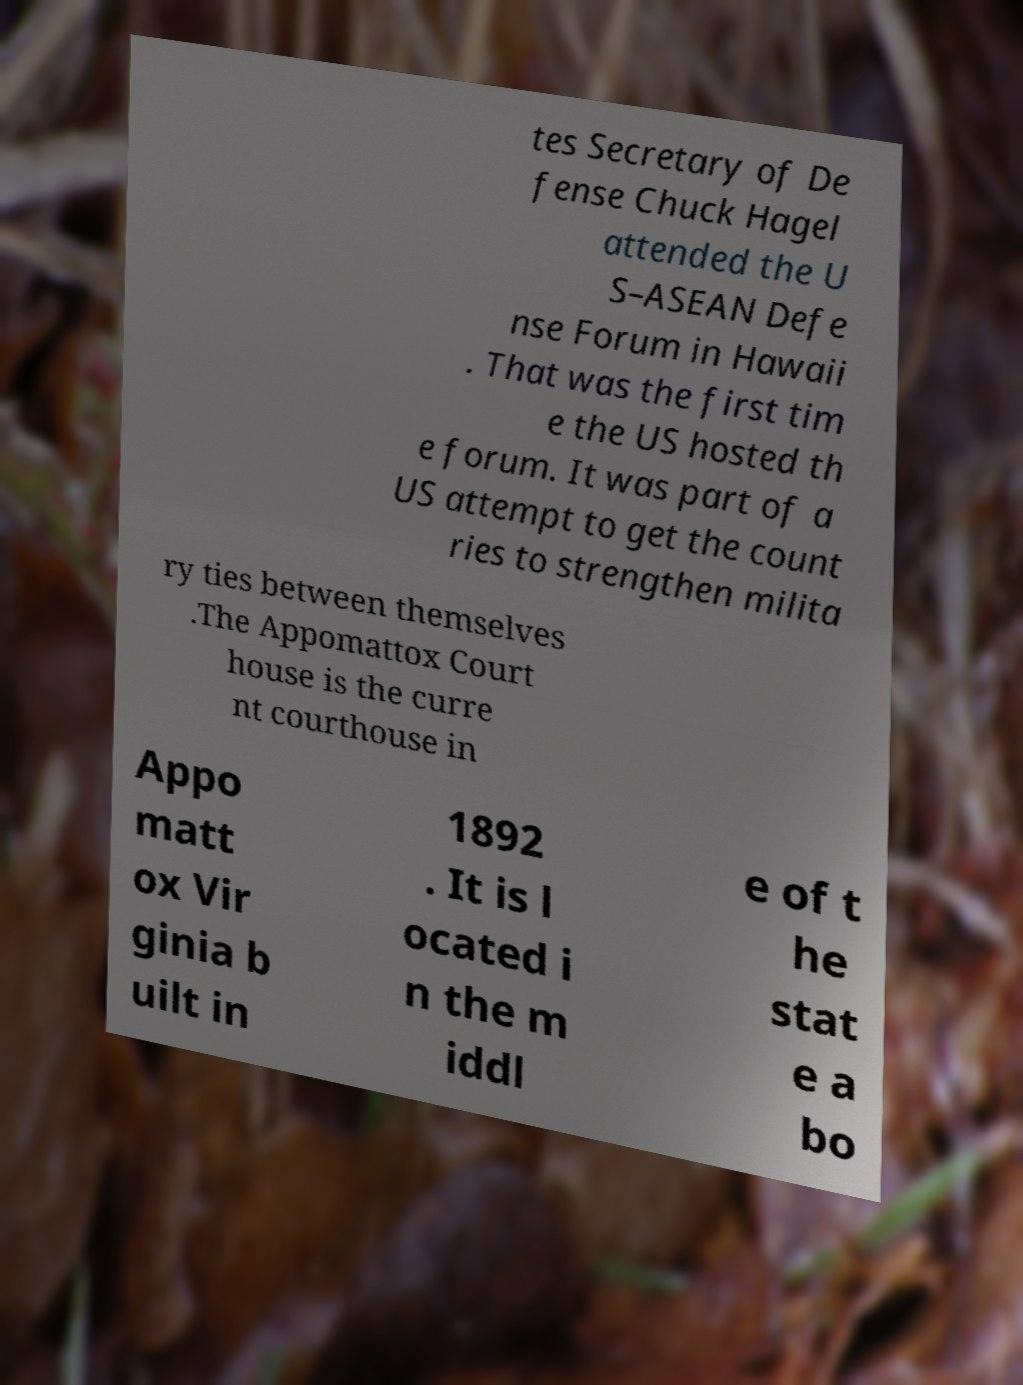Could you extract and type out the text from this image? tes Secretary of De fense Chuck Hagel attended the U S–ASEAN Defe nse Forum in Hawaii . That was the first tim e the US hosted th e forum. It was part of a US attempt to get the count ries to strengthen milita ry ties between themselves .The Appomattox Court house is the curre nt courthouse in Appo matt ox Vir ginia b uilt in 1892 . It is l ocated i n the m iddl e of t he stat e a bo 